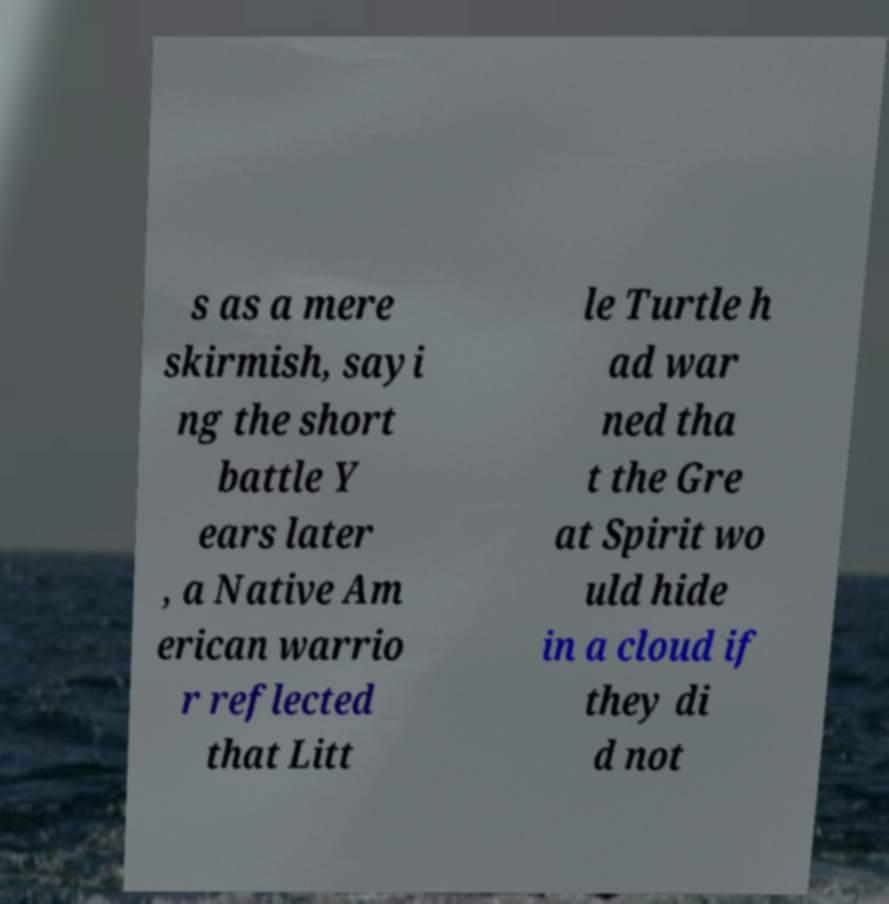I need the written content from this picture converted into text. Can you do that? s as a mere skirmish, sayi ng the short battle Y ears later , a Native Am erican warrio r reflected that Litt le Turtle h ad war ned tha t the Gre at Spirit wo uld hide in a cloud if they di d not 